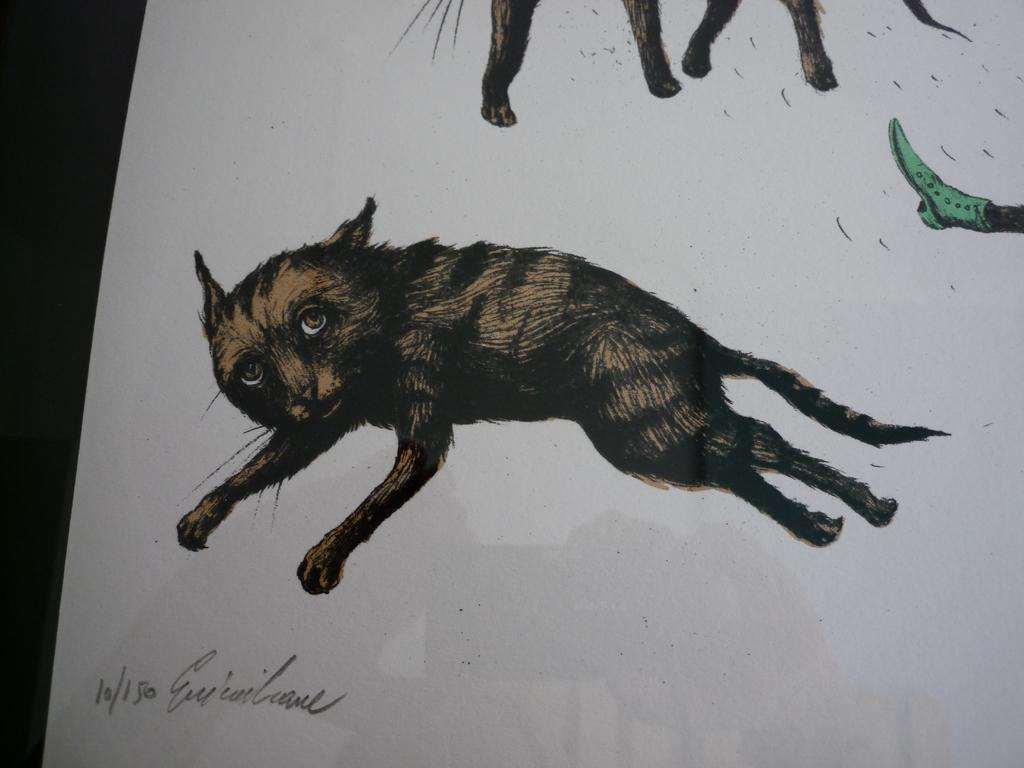What is the main subject of the paper in the image? The paper contains an image of a person's leg with a shoe. Are there any other elements on the paper besides the leg and shoe? Yes, there are animals depicted on the paper. Is there any text on the paper? Yes, there is text on the paper. What type of patch can be seen on the balloon in the image? There is no balloon present in the image; it only contains a paper with an image of a person's leg with a shoe, animals, and text. 